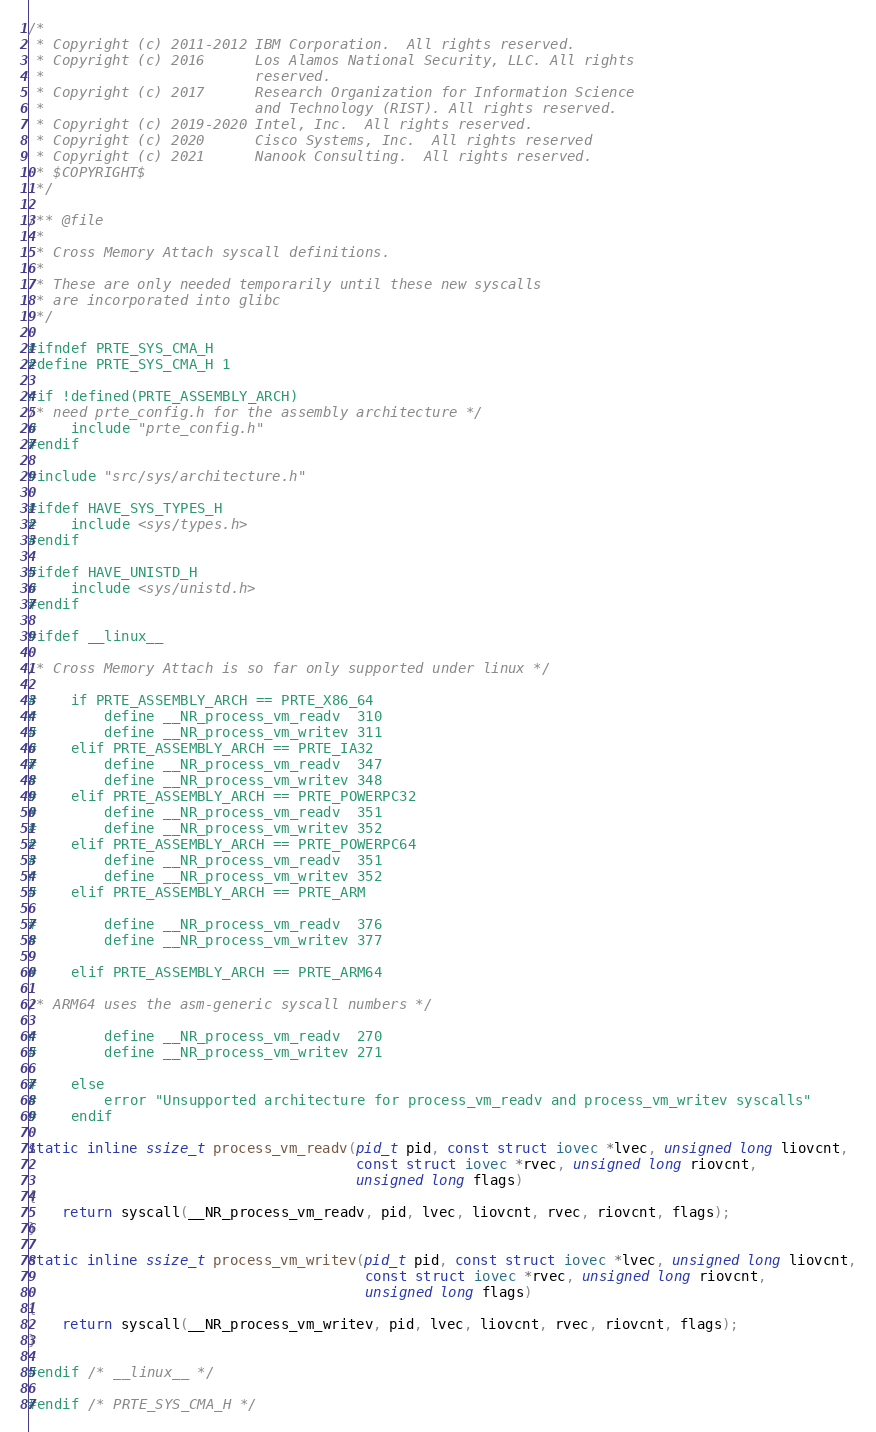Convert code to text. <code><loc_0><loc_0><loc_500><loc_500><_C_>/*
 * Copyright (c) 2011-2012 IBM Corporation.  All rights reserved.
 * Copyright (c) 2016      Los Alamos National Security, LLC. All rights
 *                         reserved.
 * Copyright (c) 2017      Research Organization for Information Science
 *                         and Technology (RIST). All rights reserved.
 * Copyright (c) 2019-2020 Intel, Inc.  All rights reserved.
 * Copyright (c) 2020      Cisco Systems, Inc.  All rights reserved
 * Copyright (c) 2021      Nanook Consulting.  All rights reserved.
 * $COPYRIGHT$
 */

/** @file
 *
 * Cross Memory Attach syscall definitions.
 *
 * These are only needed temporarily until these new syscalls
 * are incorporated into glibc
 */

#ifndef PRTE_SYS_CMA_H
#define PRTE_SYS_CMA_H 1

#if !defined(PRTE_ASSEMBLY_ARCH)
/* need prte_config.h for the assembly architecture */
#    include "prte_config.h"
#endif

#include "src/sys/architecture.h"

#ifdef HAVE_SYS_TYPES_H
#    include <sys/types.h>
#endif

#ifdef HAVE_UNISTD_H
#    include <sys/unistd.h>
#endif

#ifdef __linux__

/* Cross Memory Attach is so far only supported under linux */

#    if PRTE_ASSEMBLY_ARCH == PRTE_X86_64
#        define __NR_process_vm_readv  310
#        define __NR_process_vm_writev 311
#    elif PRTE_ASSEMBLY_ARCH == PRTE_IA32
#        define __NR_process_vm_readv  347
#        define __NR_process_vm_writev 348
#    elif PRTE_ASSEMBLY_ARCH == PRTE_POWERPC32
#        define __NR_process_vm_readv  351
#        define __NR_process_vm_writev 352
#    elif PRTE_ASSEMBLY_ARCH == PRTE_POWERPC64
#        define __NR_process_vm_readv  351
#        define __NR_process_vm_writev 352
#    elif PRTE_ASSEMBLY_ARCH == PRTE_ARM

#        define __NR_process_vm_readv  376
#        define __NR_process_vm_writev 377

#    elif PRTE_ASSEMBLY_ARCH == PRTE_ARM64

/* ARM64 uses the asm-generic syscall numbers */

#        define __NR_process_vm_readv  270
#        define __NR_process_vm_writev 271

#    else
#        error "Unsupported architecture for process_vm_readv and process_vm_writev syscalls"
#    endif

static inline ssize_t process_vm_readv(pid_t pid, const struct iovec *lvec, unsigned long liovcnt,
                                       const struct iovec *rvec, unsigned long riovcnt,
                                       unsigned long flags)
{
    return syscall(__NR_process_vm_readv, pid, lvec, liovcnt, rvec, riovcnt, flags);
}

static inline ssize_t process_vm_writev(pid_t pid, const struct iovec *lvec, unsigned long liovcnt,
                                        const struct iovec *rvec, unsigned long riovcnt,
                                        unsigned long flags)
{
    return syscall(__NR_process_vm_writev, pid, lvec, liovcnt, rvec, riovcnt, flags);
}

#endif /* __linux__ */

#endif /* PRTE_SYS_CMA_H */
</code> 